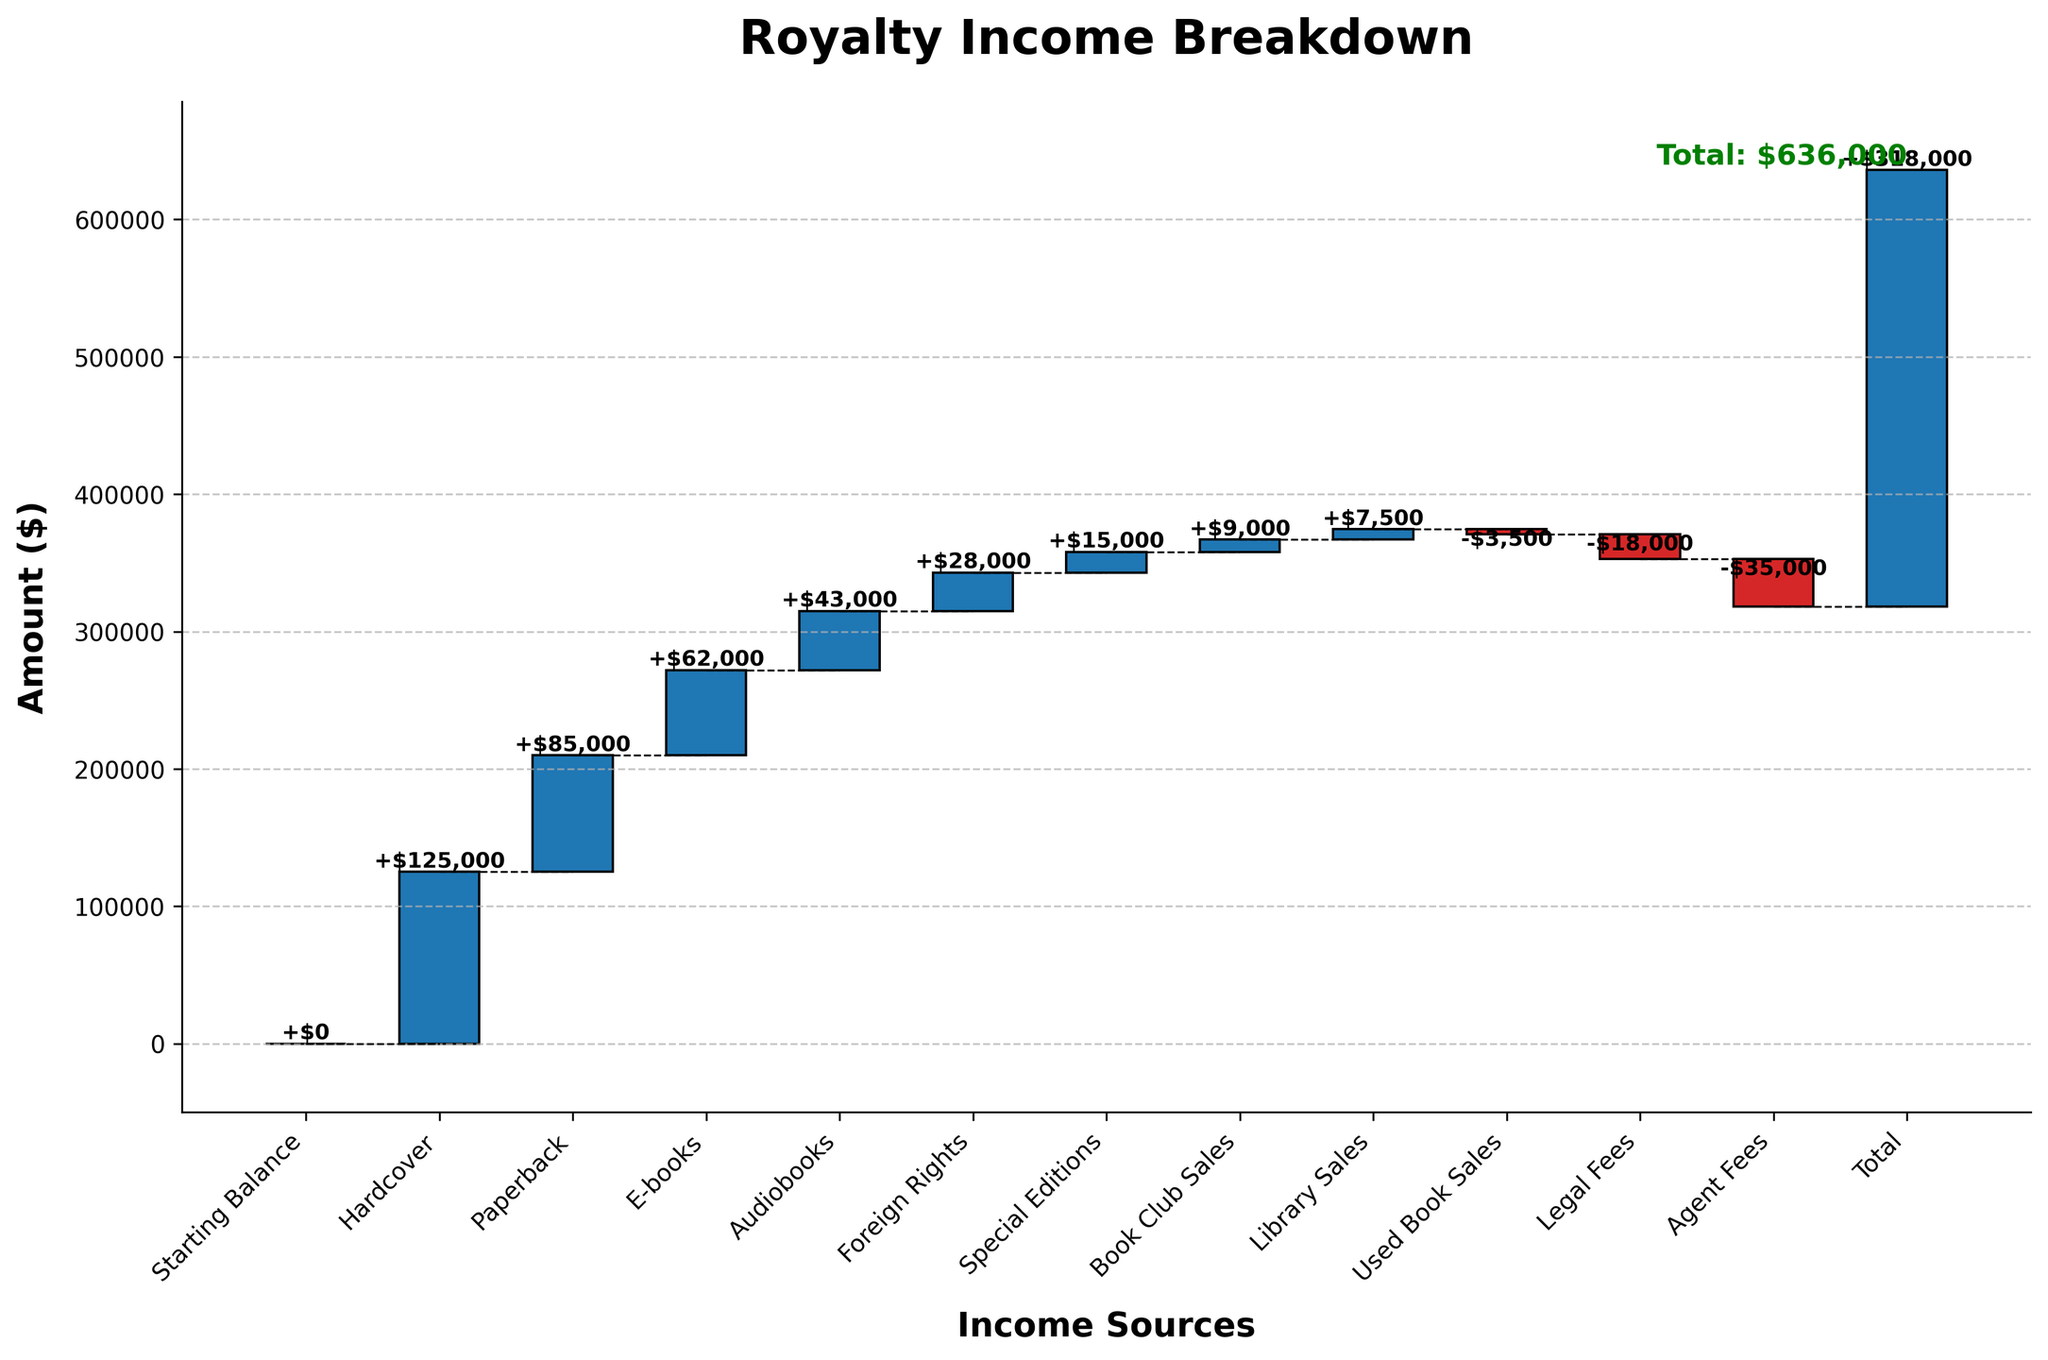What is the total royalty income at the end of the fiscal year? The final total at the end of the Waterfall Chart sums up various sources of income and expenses. By observing the cumulative value at the last data point, we find the total.
Answer: $318,000 What is the starting balance for the royalty income? The starting balance is the first data point labeled "Starting Balance" on the Waterfall Chart. Here, it is given as 0.
Answer: $0 What are the two largest sources of royalty income? By observing the heights of the bars in the Waterfall Chart, the two-largest positive contributors are "Hardcover" and "Paperback."
Answer: Hardcover and Paperback Which category has the highest expense? The bars below the cumulative line represent expenses. Observing these, "Agent Fees" is the largest negative value.
Answer: Agent Fees How much more income does Hardcover generate compared to Audiobooks? Identify the values for Hardcover (125,000) and Audiobooks (43,000). Subtract the smaller value from the larger value: 125,000 - 43,000.
Answer: $82,000 How does the income from E-books compare to Special Editions? The values for E-books (62,000) and Special Editions (15,000) can be compared directly. E-books generate more income.
Answer: E-books have higher income What is the combined income from Foreign Rights and Library Sales? Foreign Rights contribute 28,000, and Library Sales add 7,500. Summing these values: 28,000 + 7,500.
Answer: $35,500 What are the cumulative values at the midpoint of the chart (after Foreign Rights)? Summing the contributions up to and including Foreign Rights: 0 + 125,000 + 85,000 + 62,000 + 43,000 + 28,000.
Answer: $343,000 Which income category has the smallest positive contribution? Among positive contributions, the smallest bar is for "Book Club Sales" at 9,000.
Answer: Book Club Sales By how much does the "Legal Fees" expense reduce the total income? "Legal Fees" reduce the total income by 18,000, as shown by a negative bar.
Answer: $18,000 